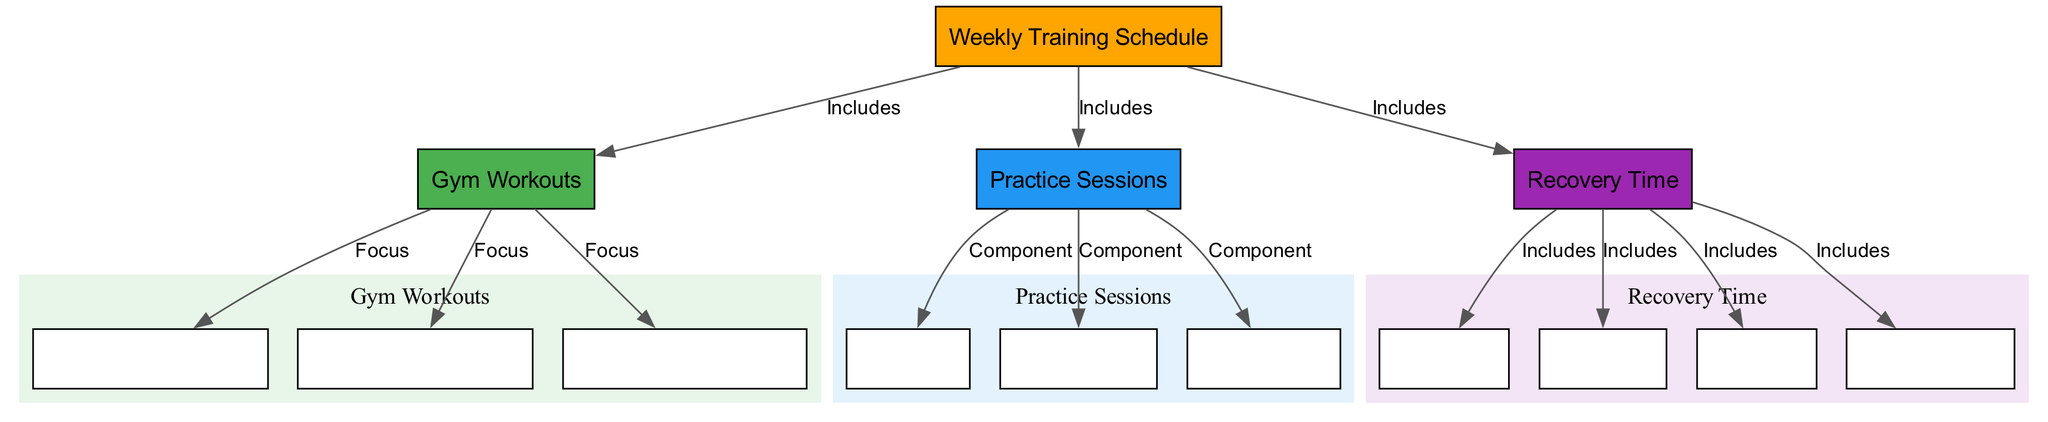What are the three main categories in the Weekly Training Schedule? The diagram indicates three main categories under the Weekly Training Schedule: Gym Workouts, Practice Sessions, and Recovery Time.
Answer: Gym Workouts, Practice Sessions, Recovery Time How many components are included in the Practice Sessions? The Practice Sessions node includes three components: Skill Drills, Team Tactics, and Scrimmages. These components are directly linked to the Practice Sessions node in the diagram.
Answer: 3 Which nodes are focused on in the Gym Workouts? The Gym Workouts node focuses on three specific areas: Upper Body Strength, Lower Body Strength, and Cardio & Conditioning. Each of these nodes is connected to Gym Workouts, indicating their specific focus.
Answer: Upper Body Strength, Lower Body Strength, Cardio & Conditioning What is a component in the Practice Sessions that involves gameplay? Scrimmages are a component in the Practice Sessions focused on gameplay. The diagram directly states this relationship through the edges connecting Practice Sessions to Scrimmages.
Answer: Scrimmages What recovery methods are included in the Recovery Time? Recovery Time includes four methods: Rest Days, Stretching, Ice Baths, and Physiotherapy, as indicated by the edges that connect these nodes to the Recovery Time node.
Answer: Rest Days, Stretching, Ice Baths, Physiotherapy Are all recovery methods linked to the Recovery Time? Yes, all the listed methods (Rest Days, Stretching, Ice Baths, Physiotherapy) are linked to the Recovery Time node in the diagram, indicating that they are all included in the recovery process.
Answer: Yes Which category do "Skill Drills" belong to? Skill Drills are a component under the Practice Sessions category, as indicated by the directed edge from Practice Sessions to Skill Drills.
Answer: Practice Sessions What type of activities are included under Gym Workouts? Gym Workouts include activities focused on Upper Body Strength, Lower Body Strength, and Cardio & Conditioning. This is noted in the diagram by their specific connections to the Gym Workouts node.
Answer: Upper Body Strength, Lower Body Strength, Cardio & Conditioning 